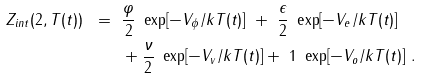<formula> <loc_0><loc_0><loc_500><loc_500>Z _ { i n t } ( 2 , T ( t ) ) \ = \ & \frac { \varphi } { 2 } \ \exp [ - V _ { \phi } / k T ( t ) ] \ + \ \frac { \epsilon } { 2 } \ \exp [ - V _ { e } / k T ( t ) ] \\ & + \frac { \nu } { 2 } \ \exp [ - V _ { v } / k T ( t ) ] + \ 1 \ \exp [ - V _ { o } / k T ( t ) ] \ .</formula> 